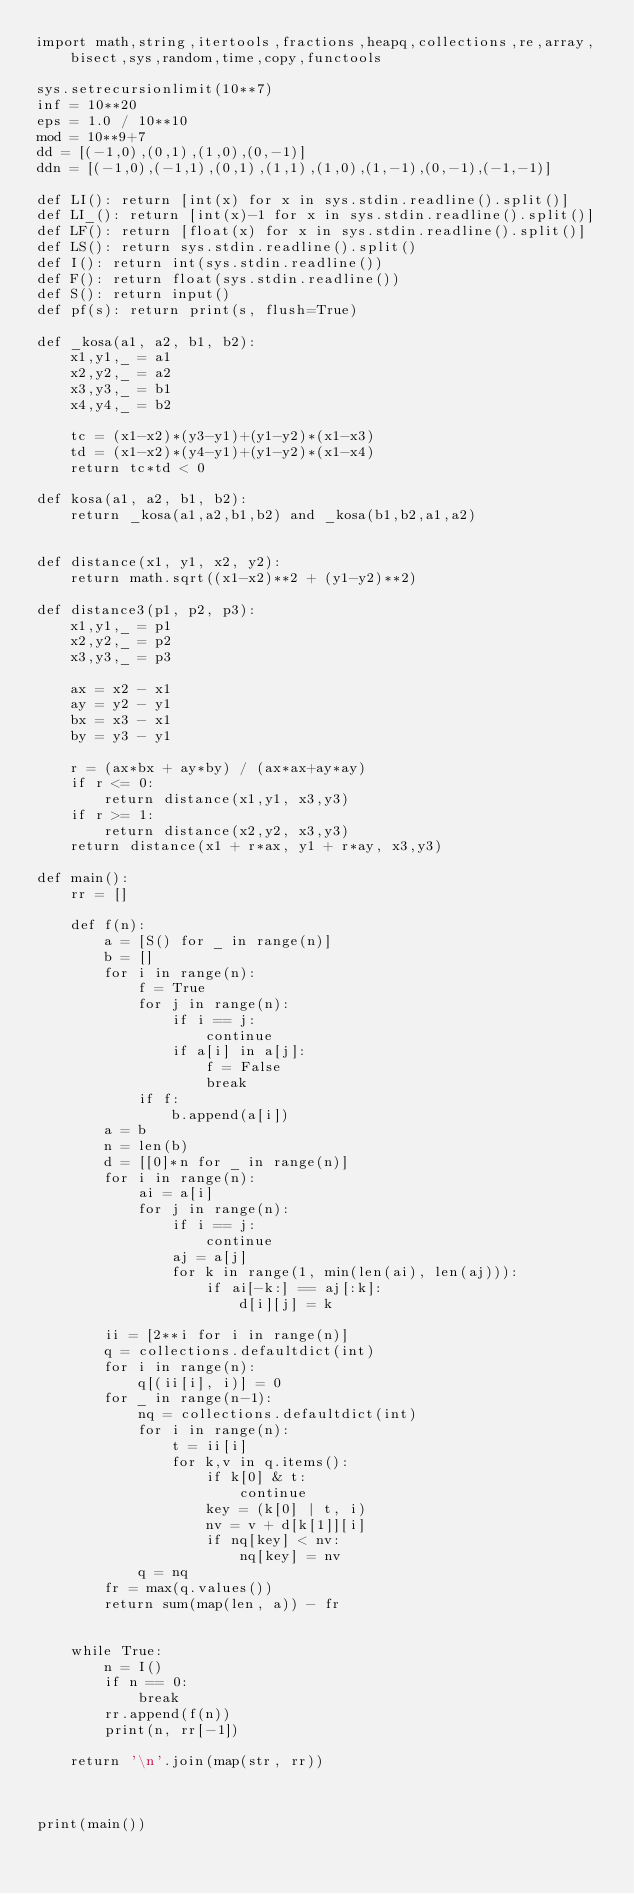<code> <loc_0><loc_0><loc_500><loc_500><_Python_>import math,string,itertools,fractions,heapq,collections,re,array,bisect,sys,random,time,copy,functools

sys.setrecursionlimit(10**7)
inf = 10**20
eps = 1.0 / 10**10
mod = 10**9+7
dd = [(-1,0),(0,1),(1,0),(0,-1)]
ddn = [(-1,0),(-1,1),(0,1),(1,1),(1,0),(1,-1),(0,-1),(-1,-1)]

def LI(): return [int(x) for x in sys.stdin.readline().split()]
def LI_(): return [int(x)-1 for x in sys.stdin.readline().split()]
def LF(): return [float(x) for x in sys.stdin.readline().split()]
def LS(): return sys.stdin.readline().split()
def I(): return int(sys.stdin.readline())
def F(): return float(sys.stdin.readline())
def S(): return input()
def pf(s): return print(s, flush=True)

def _kosa(a1, a2, b1, b2):
    x1,y1,_ = a1
    x2,y2,_ = a2
    x3,y3,_ = b1
    x4,y4,_ = b2

    tc = (x1-x2)*(y3-y1)+(y1-y2)*(x1-x3)
    td = (x1-x2)*(y4-y1)+(y1-y2)*(x1-x4)
    return tc*td < 0

def kosa(a1, a2, b1, b2):
    return _kosa(a1,a2,b1,b2) and _kosa(b1,b2,a1,a2)


def distance(x1, y1, x2, y2):
    return math.sqrt((x1-x2)**2 + (y1-y2)**2)

def distance3(p1, p2, p3):
    x1,y1,_ = p1
    x2,y2,_ = p2
    x3,y3,_ = p3

    ax = x2 - x1
    ay = y2 - y1
    bx = x3 - x1
    by = y3 - y1

    r = (ax*bx + ay*by) / (ax*ax+ay*ay)
    if r <= 0:
        return distance(x1,y1, x3,y3)
    if r >= 1:
        return distance(x2,y2, x3,y3)
    return distance(x1 + r*ax, y1 + r*ay, x3,y3)

def main():
    rr = []

    def f(n):
        a = [S() for _ in range(n)]
        b = []
        for i in range(n):
            f = True
            for j in range(n):
                if i == j:
                    continue
                if a[i] in a[j]:
                    f = False
                    break
            if f:
                b.append(a[i])
        a = b
        n = len(b)
        d = [[0]*n for _ in range(n)]
        for i in range(n):
            ai = a[i]
            for j in range(n):
                if i == j:
                    continue
                aj = a[j]
                for k in range(1, min(len(ai), len(aj))):
                    if ai[-k:] == aj[:k]:
                        d[i][j] = k

        ii = [2**i for i in range(n)]
        q = collections.defaultdict(int)
        for i in range(n):
            q[(ii[i], i)] = 0
        for _ in range(n-1):
            nq = collections.defaultdict(int)
            for i in range(n):
                t = ii[i]
                for k,v in q.items():
                    if k[0] & t:
                        continue
                    key = (k[0] | t, i)
                    nv = v + d[k[1]][i]
                    if nq[key] < nv:
                        nq[key] = nv
            q = nq
        fr = max(q.values())
        return sum(map(len, a)) - fr


    while True:
        n = I()
        if n == 0:
            break
        rr.append(f(n))
        print(n, rr[-1])

    return '\n'.join(map(str, rr))



print(main())

</code> 